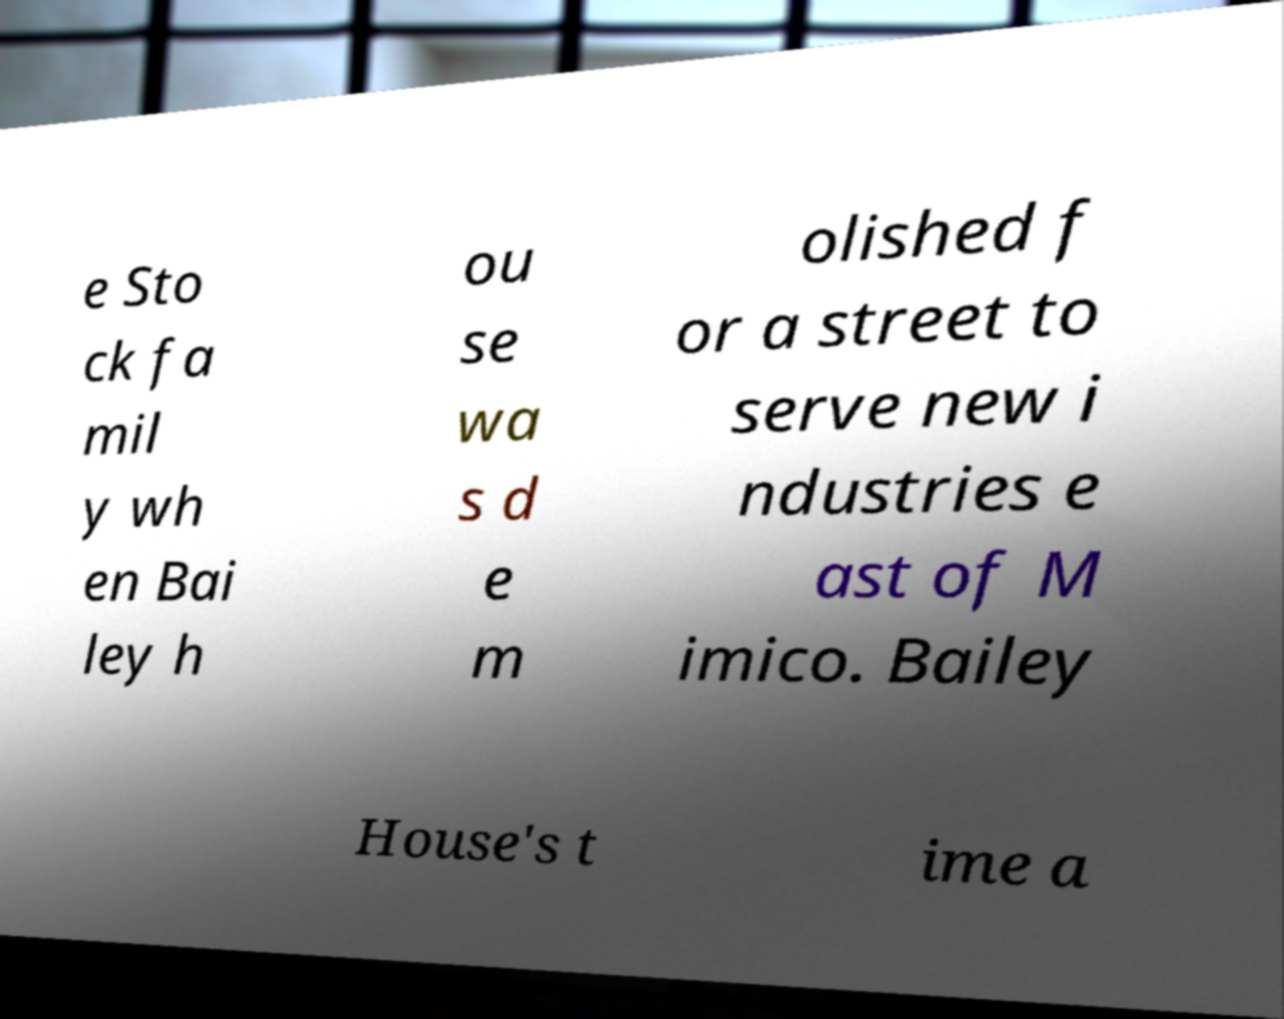Please identify and transcribe the text found in this image. e Sto ck fa mil y wh en Bai ley h ou se wa s d e m olished f or a street to serve new i ndustries e ast of M imico. Bailey House's t ime a 